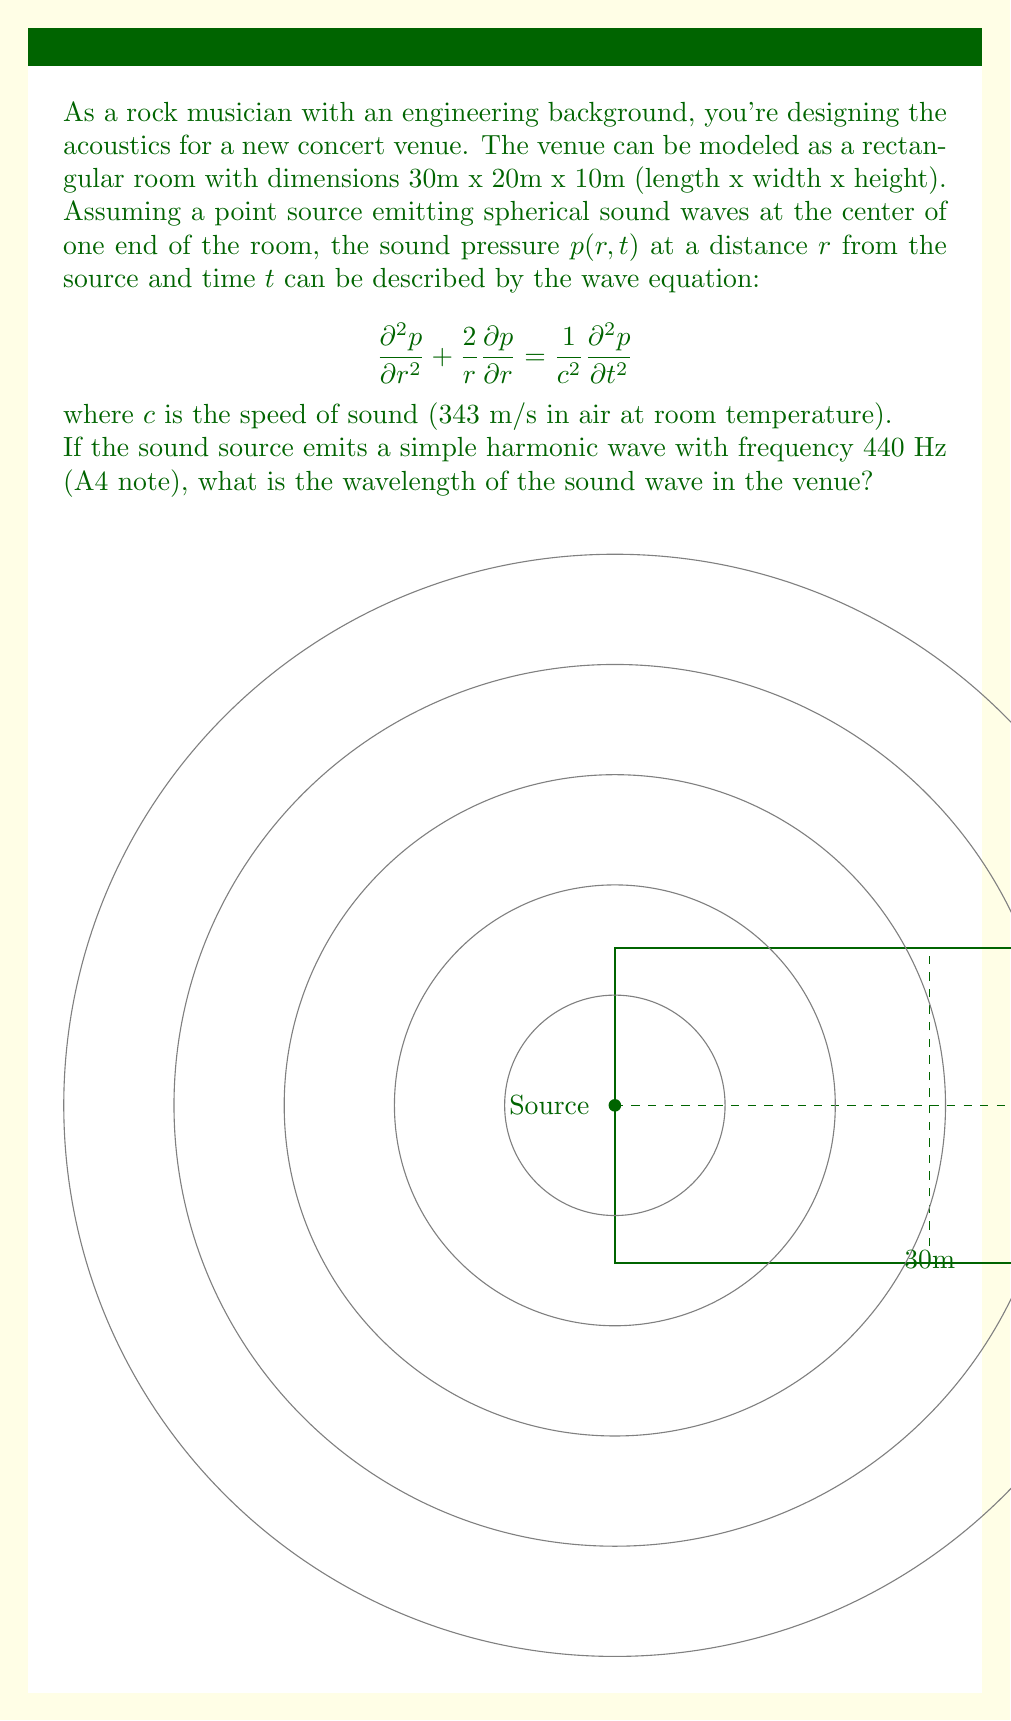Help me with this question. Let's approach this step-by-step:

1) The wavelength $\lambda$ of a sound wave is related to its frequency $f$ and the speed of sound $c$ by the equation:

   $$c = f\lambda$$

2) We are given:
   - Frequency $f = 440$ Hz (A4 note)
   - Speed of sound $c = 343$ m/s

3) Rearranging the equation to solve for $\lambda$:

   $$\lambda = \frac{c}{f}$$

4) Substituting the known values:

   $$\lambda = \frac{343 \text{ m/s}}{440 \text{ Hz}}$$

5) Calculating:

   $$\lambda = 0.77954545... \text{ m}$$

6) Rounding to three significant figures:

   $$\lambda \approx 0.780 \text{ m}$$

Note: While the wave equation provided in the question is important for understanding the propagation of sound in the venue, it's not directly needed to calculate the wavelength in this case. However, it would be crucial for more complex analyses of the sound field within the venue.
Answer: $0.780 \text{ m}$ 